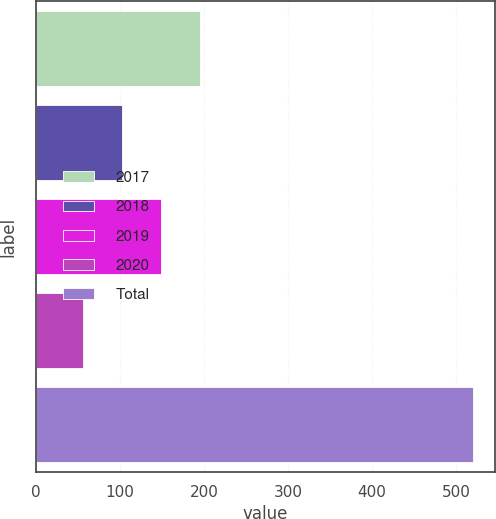<chart> <loc_0><loc_0><loc_500><loc_500><bar_chart><fcel>2017<fcel>2018<fcel>2019<fcel>2020<fcel>Total<nl><fcel>195.5<fcel>102.5<fcel>149<fcel>56<fcel>521<nl></chart> 